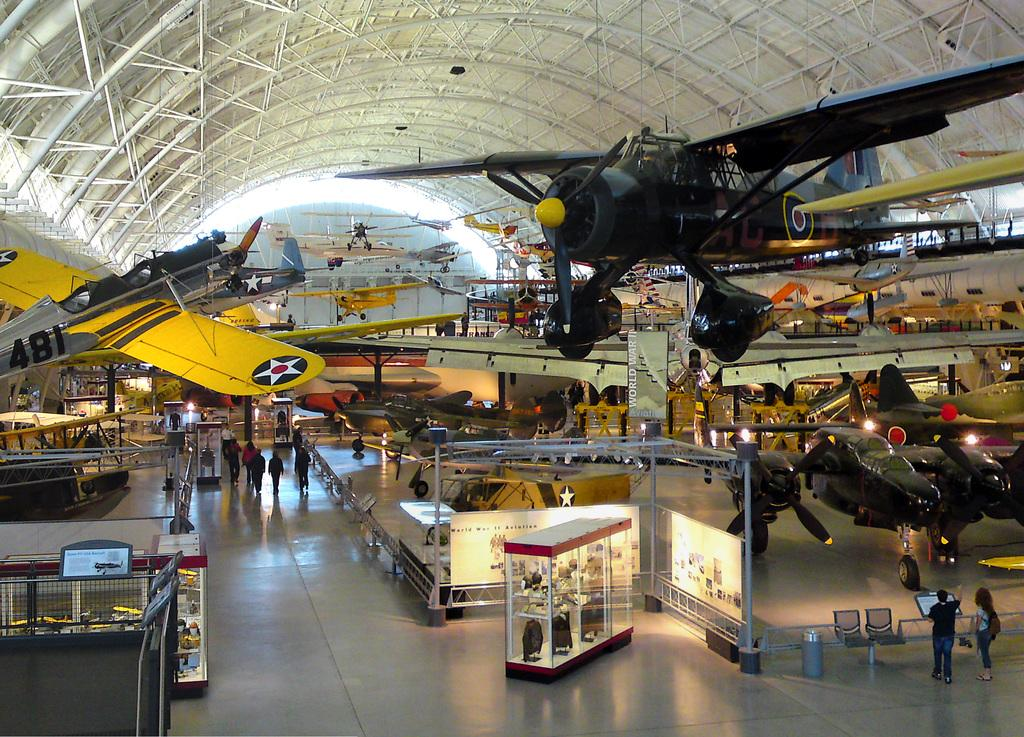<image>
Give a short and clear explanation of the subsequent image. Museum full of different planes  and a sign in the front that says "WORLD WAR II". 